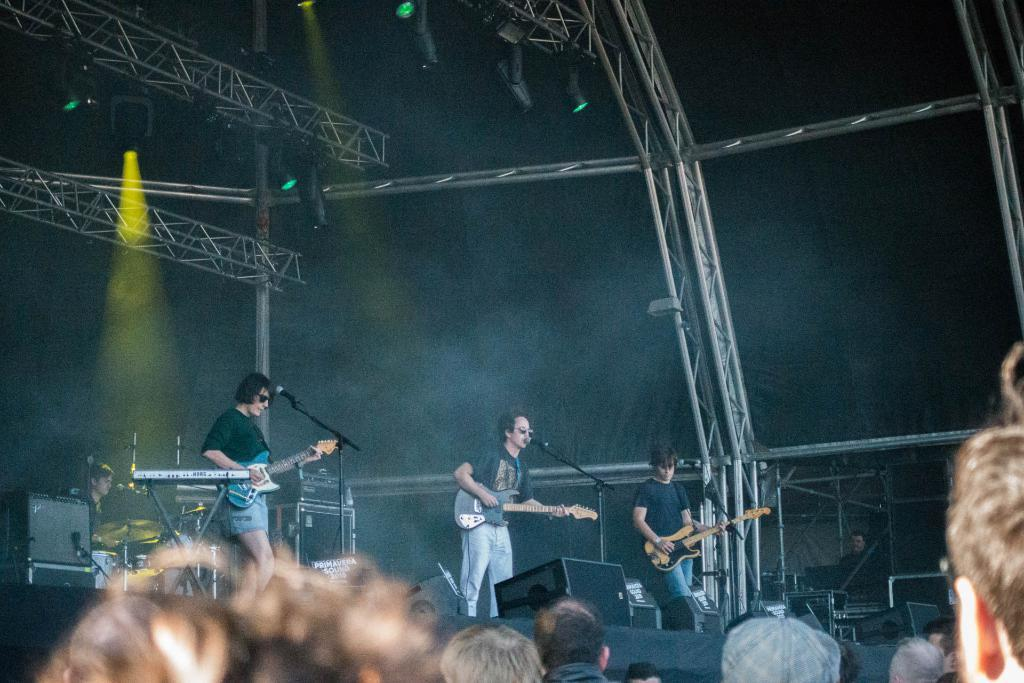What event is taking place in the image? There is a concert happening in the image. How many performers are on stage during the concert? There are three to four people on stage performing. Who is present in the image besides the performers? There is an audience in the image. What is the audience doing during the concert? The audience is watching the performers. What type of hammer is being used by the performers on stage? There is no hammer present in the image; the performers are not using any tools. What kind of chain is connecting the performers on stage? There is no chain present in the image; the performers are not connected by any physical objects. 